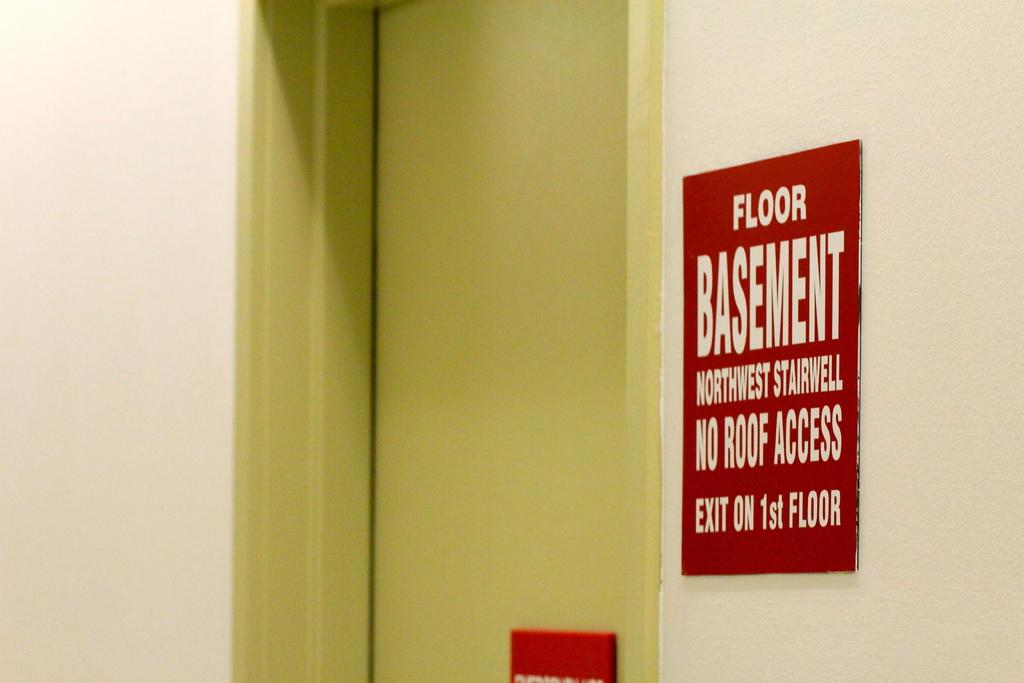<image>
Summarize the visual content of the image. Red sign saying "Floor Basement" next to a yellow door. 